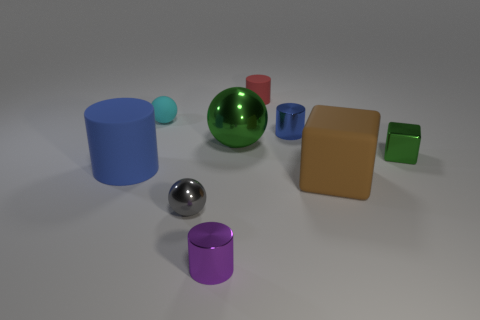Subtract 1 cylinders. How many cylinders are left? 3 Subtract all yellow cylinders. Subtract all purple spheres. How many cylinders are left? 4 Add 1 small green matte things. How many objects exist? 10 Subtract all cylinders. How many objects are left? 5 Add 7 tiny rubber cylinders. How many tiny rubber cylinders exist? 8 Subtract 0 blue blocks. How many objects are left? 9 Subtract all tiny brown cubes. Subtract all green blocks. How many objects are left? 8 Add 5 big brown things. How many big brown things are left? 6 